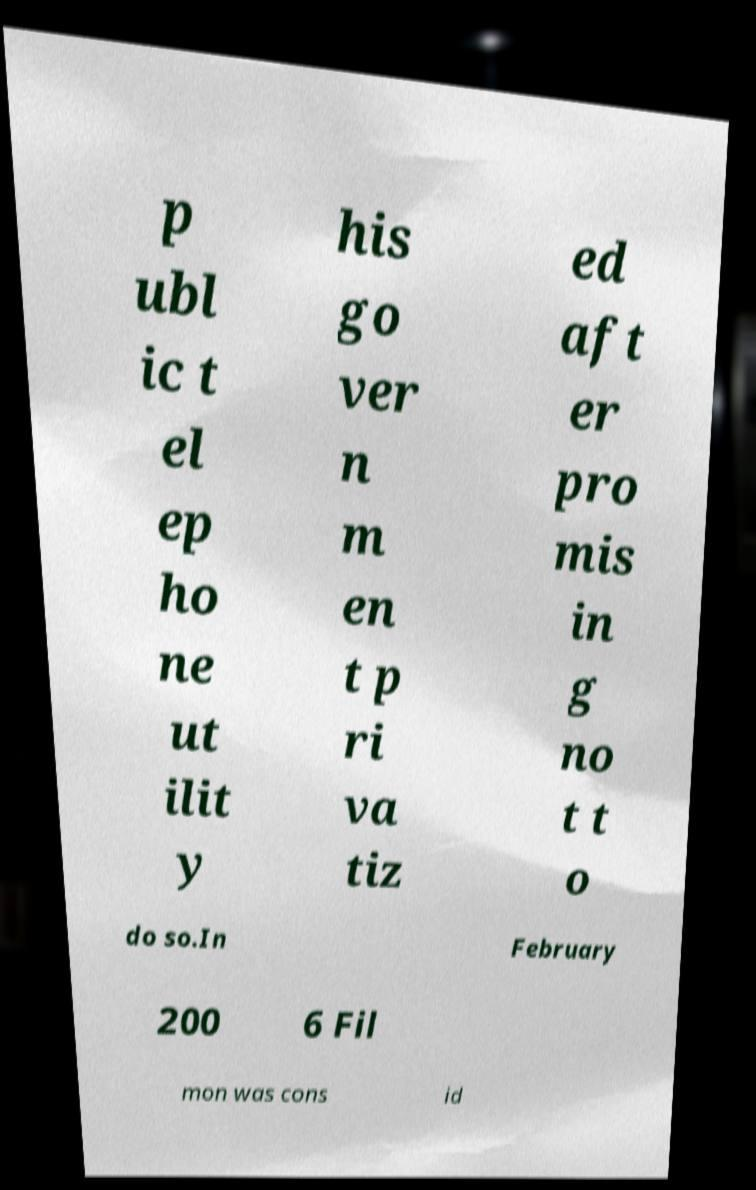Please read and relay the text visible in this image. What does it say? p ubl ic t el ep ho ne ut ilit y his go ver n m en t p ri va tiz ed aft er pro mis in g no t t o do so.In February 200 6 Fil mon was cons id 